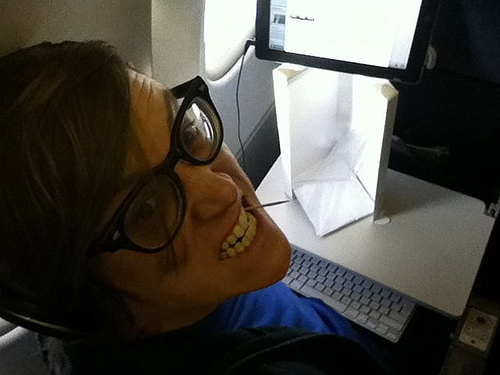Is there either a open window or door? Yes, there is an open window or door. 